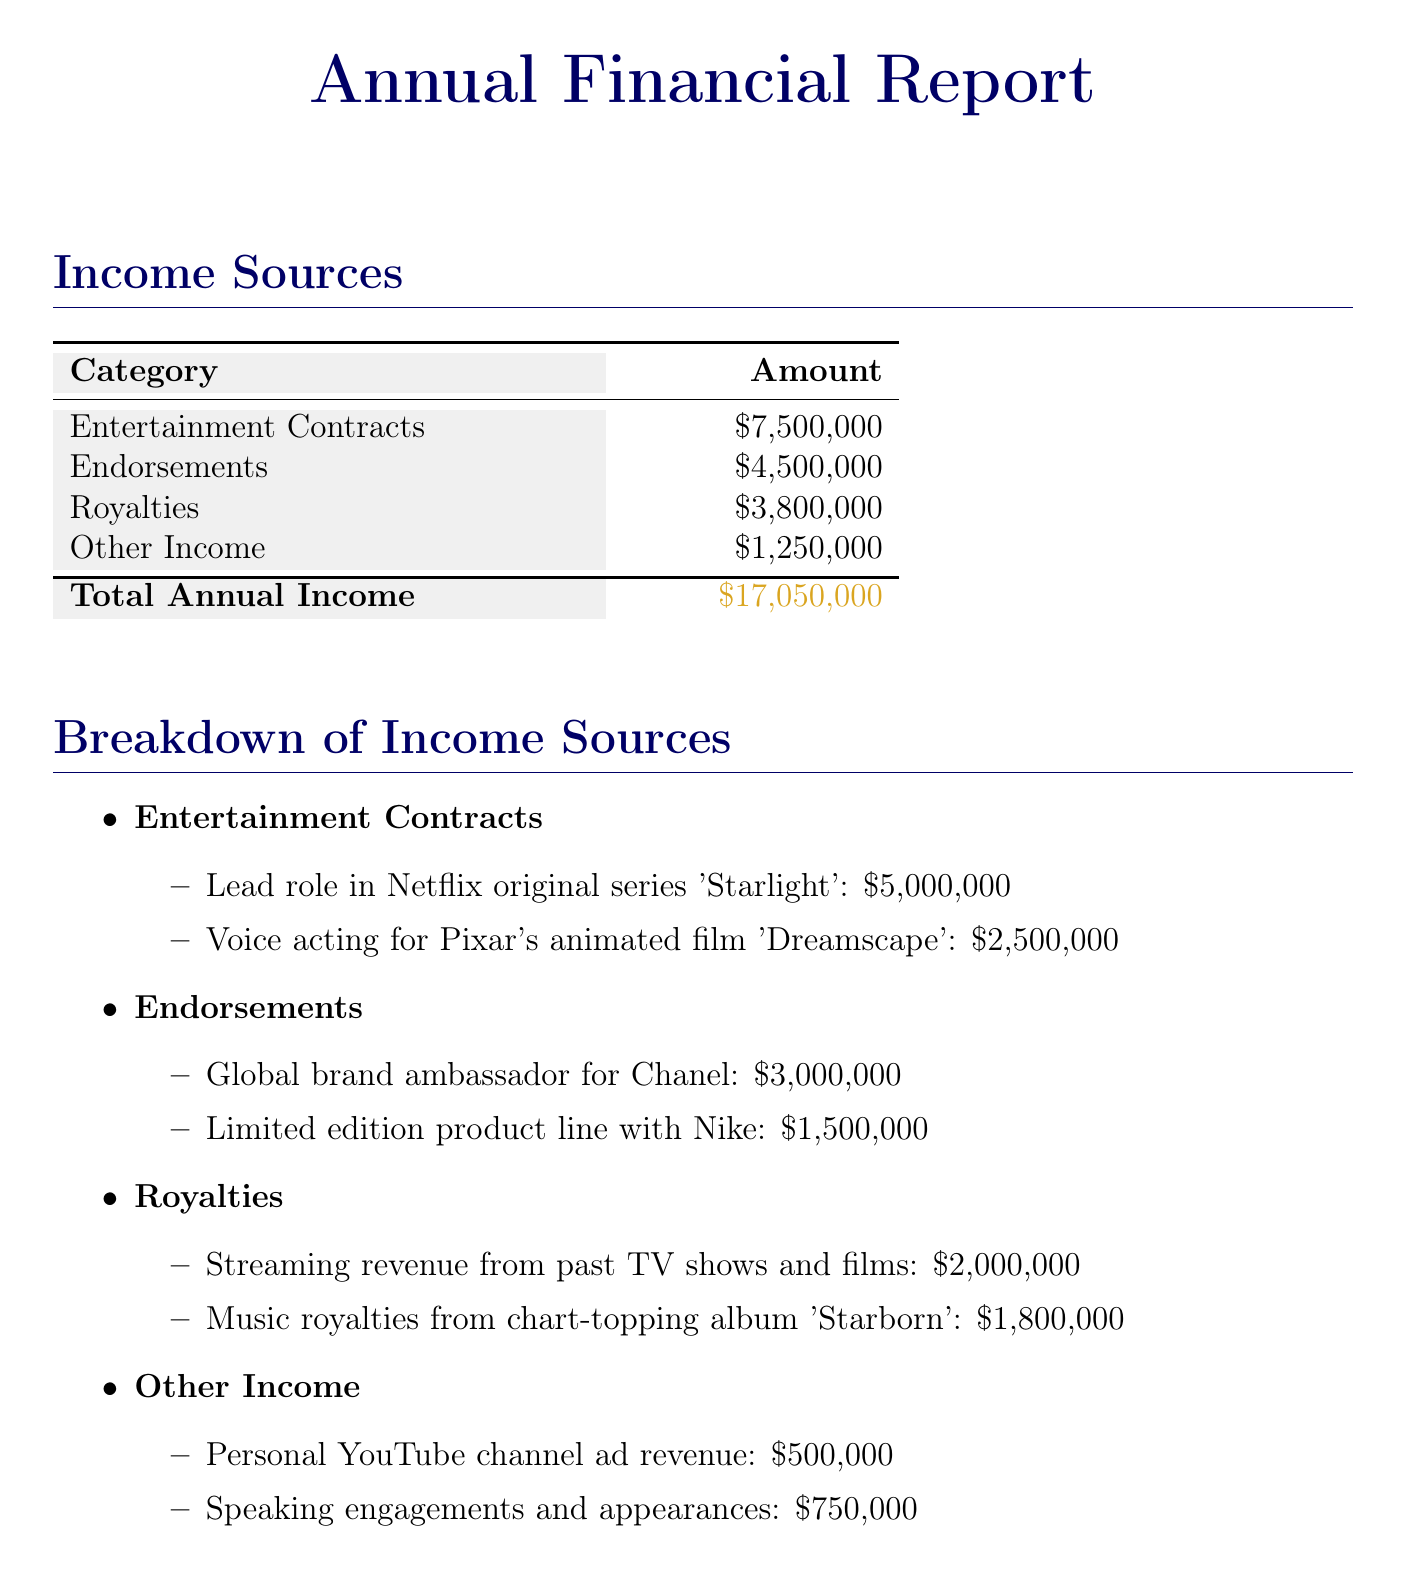What is the total annual income? The total annual income is presented at the bottom of the income sources table as the sum of all income categories.
Answer: $17,050,000 How much did the lead role in 'Starlight' earn? The income from the lead role in the Netflix series 'Starlight' is detailed under entertainment contracts.
Answer: $5,000,000 What is the income from endorsements? The total amount listed under the endorsements category sums up the specific amounts for each endorsement deal mentioned.
Answer: $4,500,000 What category generates the most income? By comparing the amounts in the income sources table, it's evident which category has the highest figure.
Answer: Entertainment Contracts What is the amount earned from music royalties? The music royalties from the album 'Starborn' can be found in the breakdown of the royalties section.
Answer: $1,800,000 How much is earned from other income sources? This amount is calculated from the two items listed under the other income category.
Answer: $1,250,000 Are all figures pre-tax? The notes section specifies that all figures mentioned in the document are pre-tax.
Answer: Yes What is the income from streaming revenue? The amount associated with streaming revenue is found in the breakdown under royalties.
Answer: $2,000,000 What subject is the income from personal YouTube channel ad revenue listed under? This income is categorized specifically under other income in the breakdown of income sources.
Answer: Other Income 